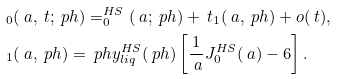Convert formula to latex. <formula><loc_0><loc_0><loc_500><loc_500>& _ { 0 } ( \ a , \ t ; \ p h ) = _ { 0 } ^ { H S } ( \ a ; \ p h ) + \ t _ { 1 } ( \ a , \ p h ) + o ( \ t ) , \\ & _ { 1 } ( \ a , \ p h ) = \ p h y ^ { H S } _ { l i q } ( \ p h ) \left [ \frac { 1 } { \ a } J _ { 0 } ^ { H S } ( \ a ) - 6 \right ] .</formula> 